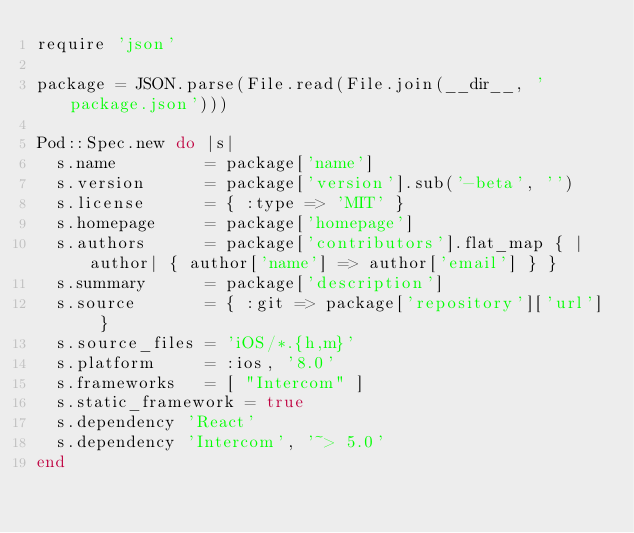Convert code to text. <code><loc_0><loc_0><loc_500><loc_500><_Ruby_>require 'json'

package = JSON.parse(File.read(File.join(__dir__, 'package.json')))

Pod::Spec.new do |s|
  s.name         = package['name']
  s.version      = package['version'].sub('-beta', '')
  s.license      = { :type => 'MIT' }
  s.homepage     = package['homepage']
  s.authors      = package['contributors'].flat_map { |author| { author['name'] => author['email'] } }
  s.summary      = package['description']
  s.source       = { :git => package['repository']['url'] }
  s.source_files = 'iOS/*.{h,m}'
  s.platform     = :ios, '8.0'
  s.frameworks   = [ "Intercom" ]
  s.static_framework = true
  s.dependency 'React'
  s.dependency 'Intercom', '~> 5.0'
end
</code> 